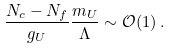<formula> <loc_0><loc_0><loc_500><loc_500>\frac { N _ { c } - N _ { f } } { g _ { U } } \frac { m _ { U } } { \Lambda } \sim \mathcal { O } ( 1 ) \, .</formula> 